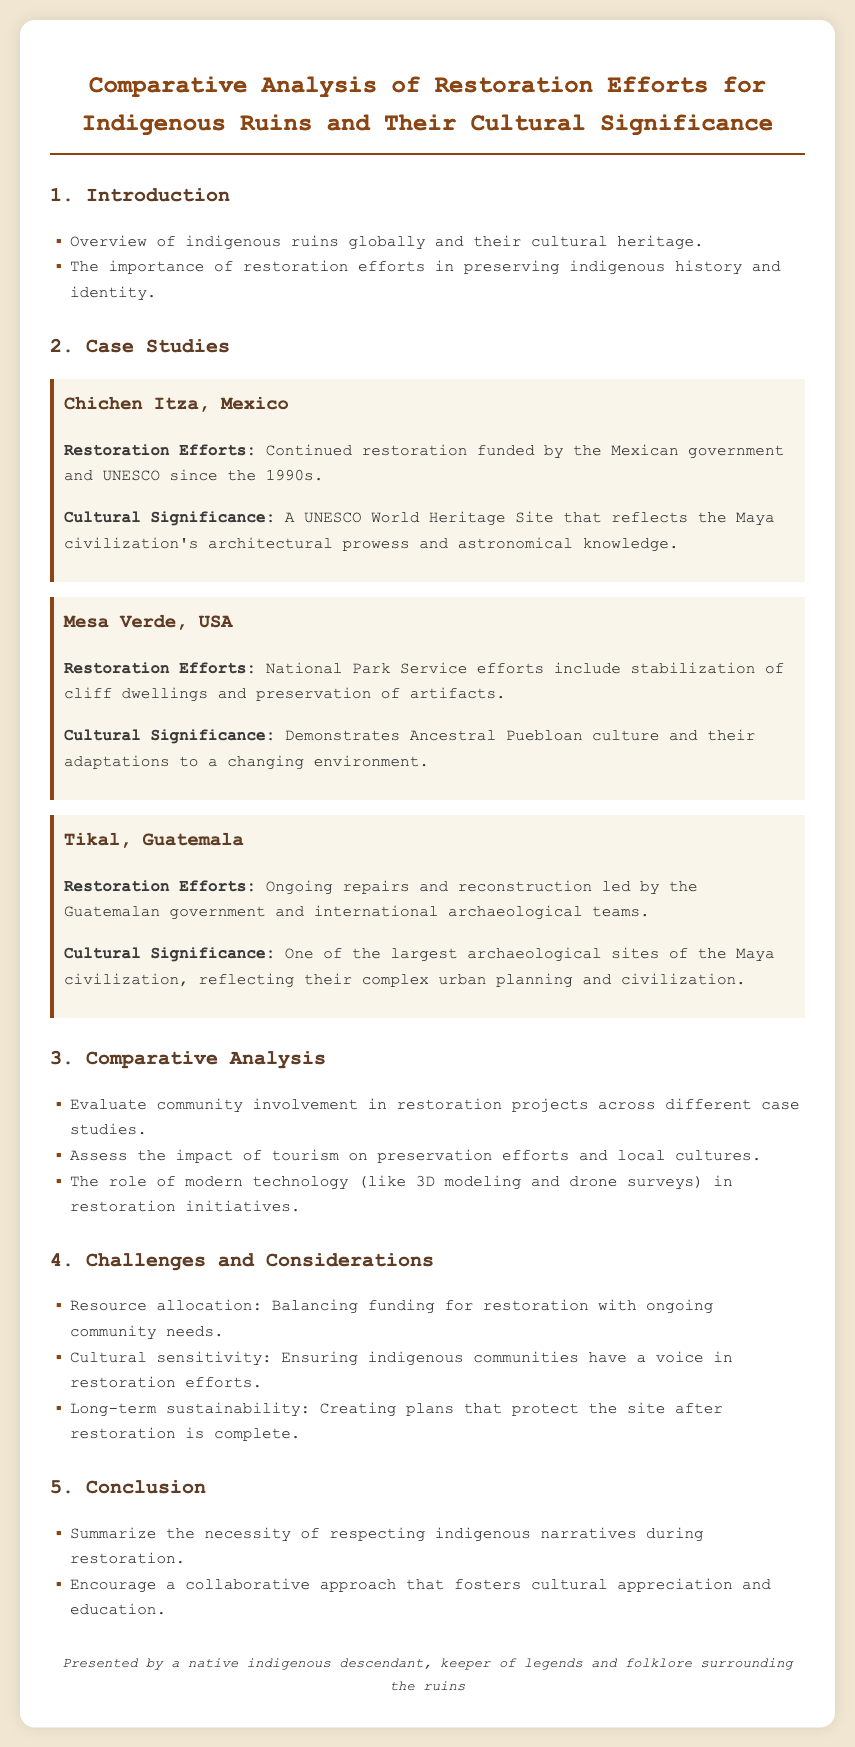What is the title of the document? The title is the main heading of the document, which introduces its content.
Answer: Comparative Analysis of Restoration Efforts for Indigenous Ruins and Their Cultural Significance Which case study is related to the Maya civilization? The case study discusses a site that is a part of the ancient Maya civilization, highlighting its importance.
Answer: Chichen Itza What restoration efforts are mentioned for Mesa Verde? This detail outlines the specific actions taken by the relevant authorities to preserve the site.
Answer: Stabilization of cliff dwellings and preservation of artifacts How many case studies are presented in the document? This refers to the total number of specific examples discussed in the case studies section.
Answer: Three What challenge refers to resources in restoration efforts? This captures the concern regarding the allocation of funds and how it impacts other community needs.
Answer: Resource allocation What role does modern technology play in restoration initiatives? This question addresses how recent technological advancements contribute to restoration efforts discussed.
Answer: Restoration initiatives What is the cultural significance of Tikal? This reflects the importance of the site concerning ancient civilization achievements mentioned in the document.
Answer: Complex urban planning and civilization Which organization has funded the restoration of Chichen Itza? This highlights the funding source involved in the ongoing preservation of the site.
Answer: UNESCO What is a consideration for long-term sustainability? This engages with the aspect of ensuring that preservation efforts last after the initial work is done.
Answer: Creating plans that protect the site after restoration is complete 